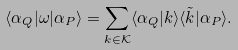Convert formula to latex. <formula><loc_0><loc_0><loc_500><loc_500>\langle \alpha _ { Q } | \omega | \alpha _ { P } \rangle = \sum _ { k \in { \mathcal { K } } } \langle \alpha _ { Q } | k \rangle \langle \tilde { k } | \alpha _ { P } \rangle .</formula> 